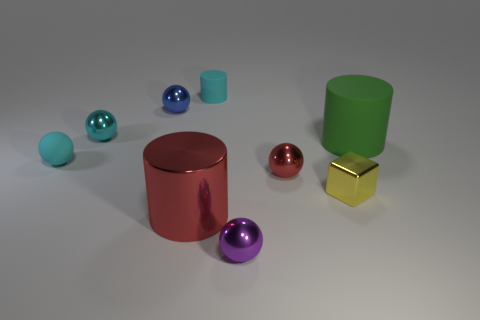What is the small cube made of?
Your answer should be very brief. Metal. What material is the small thing to the right of the tiny red metal ball?
Offer a very short reply. Metal. Are there any other things that are the same color as the tiny metallic block?
Your response must be concise. No. The cyan cylinder that is made of the same material as the big green thing is what size?
Give a very brief answer. Small. What number of large things are either purple balls or red shiny cylinders?
Provide a short and direct response. 1. There is a matte thing to the right of the sphere that is in front of the red shiny thing that is behind the red metallic cylinder; how big is it?
Make the answer very short. Large. What number of other rubber balls are the same size as the rubber ball?
Offer a very short reply. 0. How many objects are either big green cylinders or big things that are right of the small red ball?
Offer a terse response. 1. What is the shape of the big shiny thing?
Offer a very short reply. Cylinder. Do the metal cube and the rubber ball have the same color?
Ensure brevity in your answer.  No. 